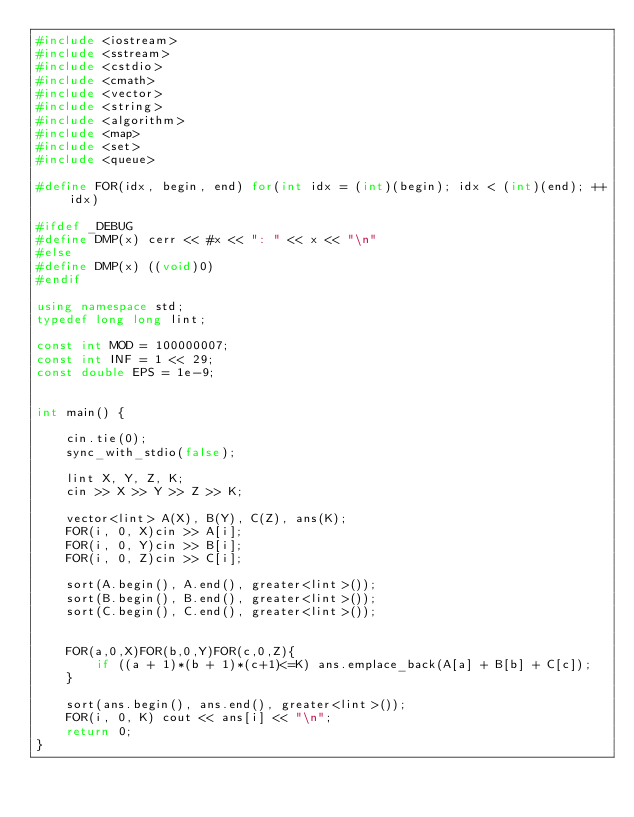Convert code to text. <code><loc_0><loc_0><loc_500><loc_500><_C++_>#include <iostream>
#include <sstream>
#include <cstdio>
#include <cmath>
#include <vector>
#include <string>
#include <algorithm>
#include <map>
#include <set>
#include <queue>

#define FOR(idx, begin, end) for(int idx = (int)(begin); idx < (int)(end); ++idx)

#ifdef _DEBUG
#define DMP(x) cerr << #x << ": " << x << "\n"
#else
#define DMP(x) ((void)0)
#endif

using namespace std;
typedef long long lint;

const int MOD = 100000007;
const int INF = 1 << 29;
const double EPS = 1e-9;


int main() {

	cin.tie(0);
  	sync_with_stdio(false);

	lint X, Y, Z, K;
	cin >> X >> Y >> Z >> K;

	vector<lint> A(X), B(Y), C(Z), ans(K);
	FOR(i, 0, X)cin >> A[i];
	FOR(i, 0, Y)cin >> B[i];
	FOR(i, 0, Z)cin >> C[i];

	sort(A.begin(), A.end(), greater<lint>());
	sort(B.begin(), B.end(), greater<lint>());
	sort(C.begin(), C.end(), greater<lint>());


	FOR(a,0,X)FOR(b,0,Y)FOR(c,0,Z){
		if ((a + 1)*(b + 1)*(c+1)<=K) ans.emplace_back(A[a] + B[b] + C[c]);
	}

	sort(ans.begin(), ans.end(), greater<lint>());
	FOR(i, 0, K) cout << ans[i] << "\n";
	return 0;
}
</code> 